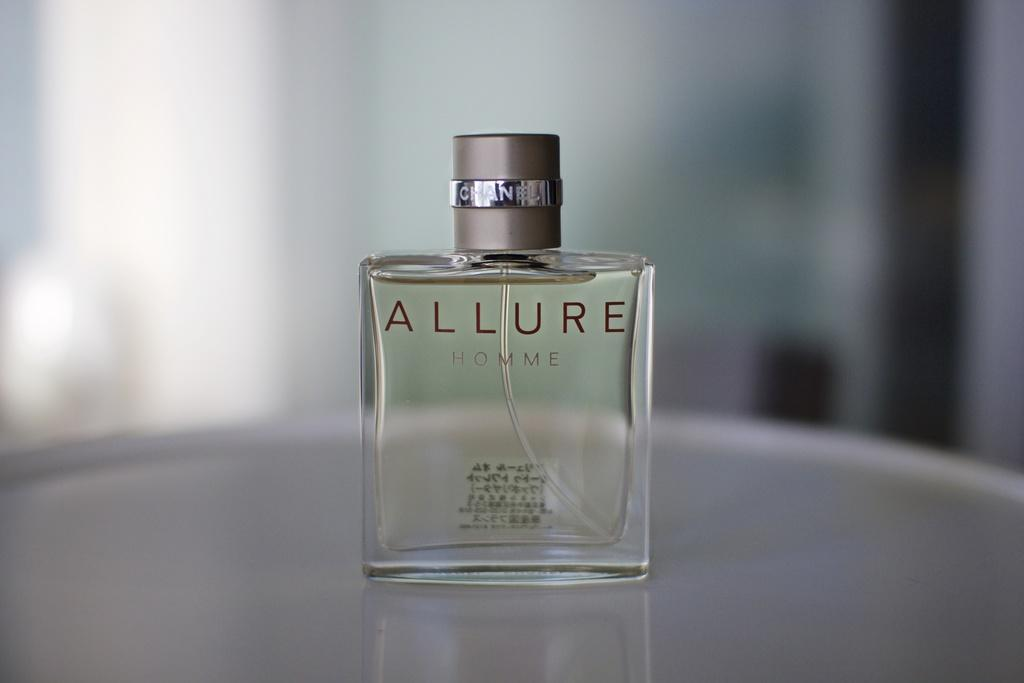<image>
Present a compact description of the photo's key features. A bottle of allure perfume sits on the table. 